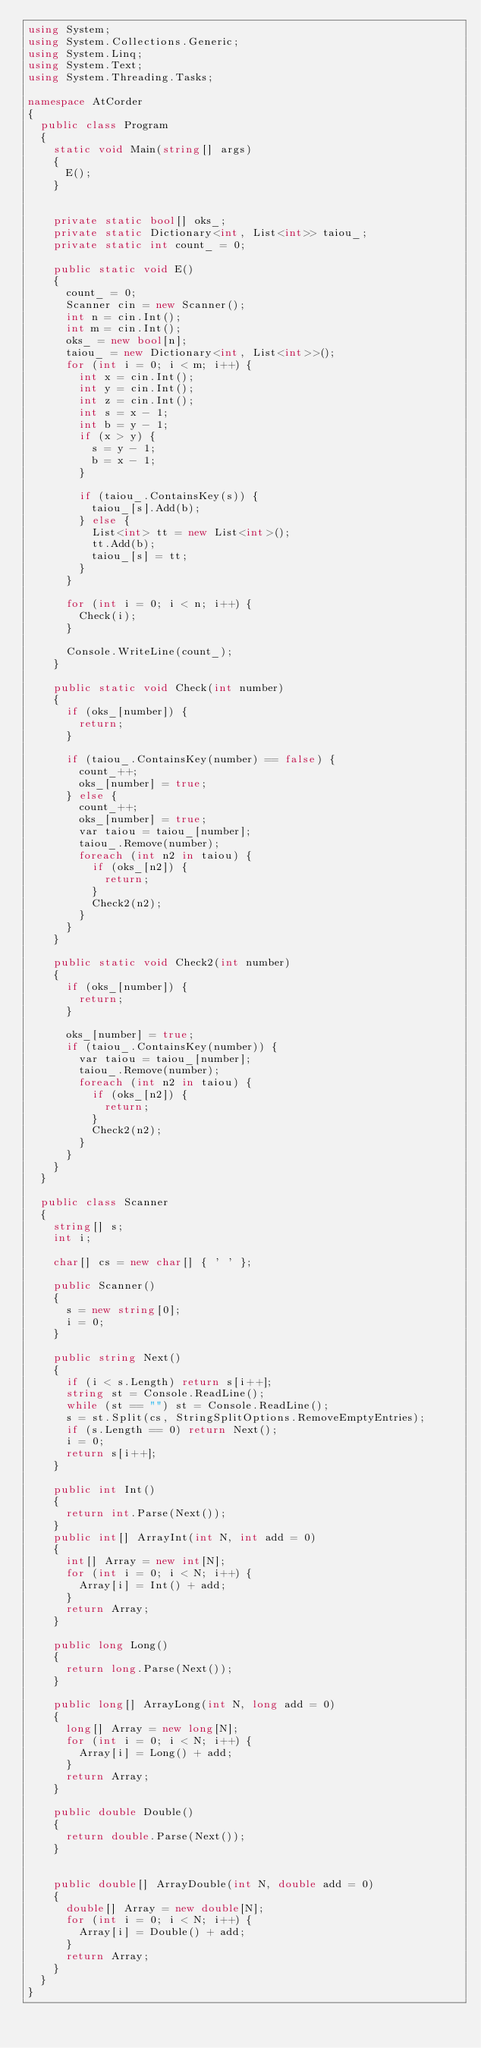Convert code to text. <code><loc_0><loc_0><loc_500><loc_500><_C#_>using System;
using System.Collections.Generic;
using System.Linq;
using System.Text;
using System.Threading.Tasks;

namespace AtCorder
{
	public class Program
	{
		static void Main(string[] args)
		{
			E();
		}


		private static bool[] oks_;
		private static Dictionary<int, List<int>> taiou_;
		private static int count_ = 0;

		public static void E()
		{
			count_ = 0;
			Scanner cin = new Scanner();
			int n = cin.Int();
			int m = cin.Int();
			oks_ = new bool[n];
			taiou_ = new Dictionary<int, List<int>>();
			for (int i = 0; i < m; i++) {
				int x = cin.Int();
				int y = cin.Int();
				int z = cin.Int();
				int s = x - 1;
				int b = y - 1;
				if (x > y) {
					s = y - 1;
					b = x - 1;
				}

				if (taiou_.ContainsKey(s)) {
					taiou_[s].Add(b);
				} else {
					List<int> tt = new List<int>();
					tt.Add(b);
					taiou_[s] = tt;
				}
			}

			for (int i = 0; i < n; i++) {
				Check(i);
			}

			Console.WriteLine(count_);
		}

		public static void Check(int number)
		{
			if (oks_[number]) {
				return;
			}

			if (taiou_.ContainsKey(number) == false) {
				count_++;
				oks_[number] = true;
			} else {
				count_++;
				oks_[number] = true;
				var taiou = taiou_[number];
				taiou_.Remove(number);
				foreach (int n2 in taiou) {
					if (oks_[n2]) {
						return;
					}
					Check2(n2);
				}
			}
		}

		public static void Check2(int number)
		{
			if (oks_[number]) {
				return;
			}

			oks_[number] = true;
			if (taiou_.ContainsKey(number)) {
				var taiou = taiou_[number];
				taiou_.Remove(number);
				foreach (int n2 in taiou) {
					if (oks_[n2]) {
						return;
					}
					Check2(n2);
				}
			}
		}
	}

	public class Scanner
	{
		string[] s;
		int i;

		char[] cs = new char[] { ' ' };

		public Scanner()
		{
			s = new string[0];
			i = 0;
		}

		public string Next()
		{
			if (i < s.Length) return s[i++];
			string st = Console.ReadLine();
			while (st == "") st = Console.ReadLine();
			s = st.Split(cs, StringSplitOptions.RemoveEmptyEntries);
			if (s.Length == 0) return Next();
			i = 0;
			return s[i++];
		}

		public int Int()
		{
			return int.Parse(Next());
		}
		public int[] ArrayInt(int N, int add = 0)
		{
			int[] Array = new int[N];
			for (int i = 0; i < N; i++) {
				Array[i] = Int() + add;
			}
			return Array;
		}

		public long Long()
		{
			return long.Parse(Next());
		}

		public long[] ArrayLong(int N, long add = 0)
		{
			long[] Array = new long[N];
			for (int i = 0; i < N; i++) {
				Array[i] = Long() + add;
			}
			return Array;
		}

		public double Double()
		{
			return double.Parse(Next());
		}


		public double[] ArrayDouble(int N, double add = 0)
		{
			double[] Array = new double[N];
			for (int i = 0; i < N; i++) {
				Array[i] = Double() + add;
			}
			return Array;
		}
	}
}
</code> 